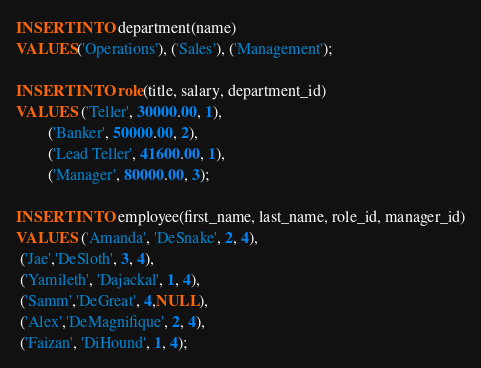Convert code to text. <code><loc_0><loc_0><loc_500><loc_500><_SQL_>INSERT INTO department(name)
VALUES('Operations'), ('Sales'), ('Management');

INSERT INTO role(title, salary, department_id)
VALUES ('Teller', 30000.00, 1),
        ('Banker', 50000.00, 2),
        ('Lead Teller', 41600.00, 1),
        ('Manager', 80000.00, 3);

INSERT INTO employee(first_name, last_name, role_id, manager_id)
VALUES ('Amanda', 'DeSnake', 2, 4),
 ('Jae','DeSloth', 3, 4),
 ('Yamileth', 'Dajackal', 1, 4),
 ('Samm','DeGreat', 4,NULL),
 ('Alex','DeMagnifique', 2, 4),
 ('Faizan', 'DiHound', 1, 4);

</code> 